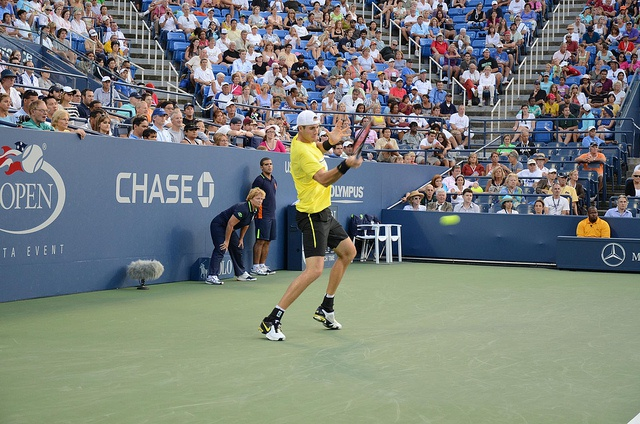Describe the objects in this image and their specific colors. I can see people in maroon, black, gray, and darkgray tones, people in maroon, black, khaki, gray, and tan tones, people in maroon, black, navy, and gray tones, people in maroon, black, and navy tones, and chair in maroon, black, lightgray, navy, and darkgray tones in this image. 